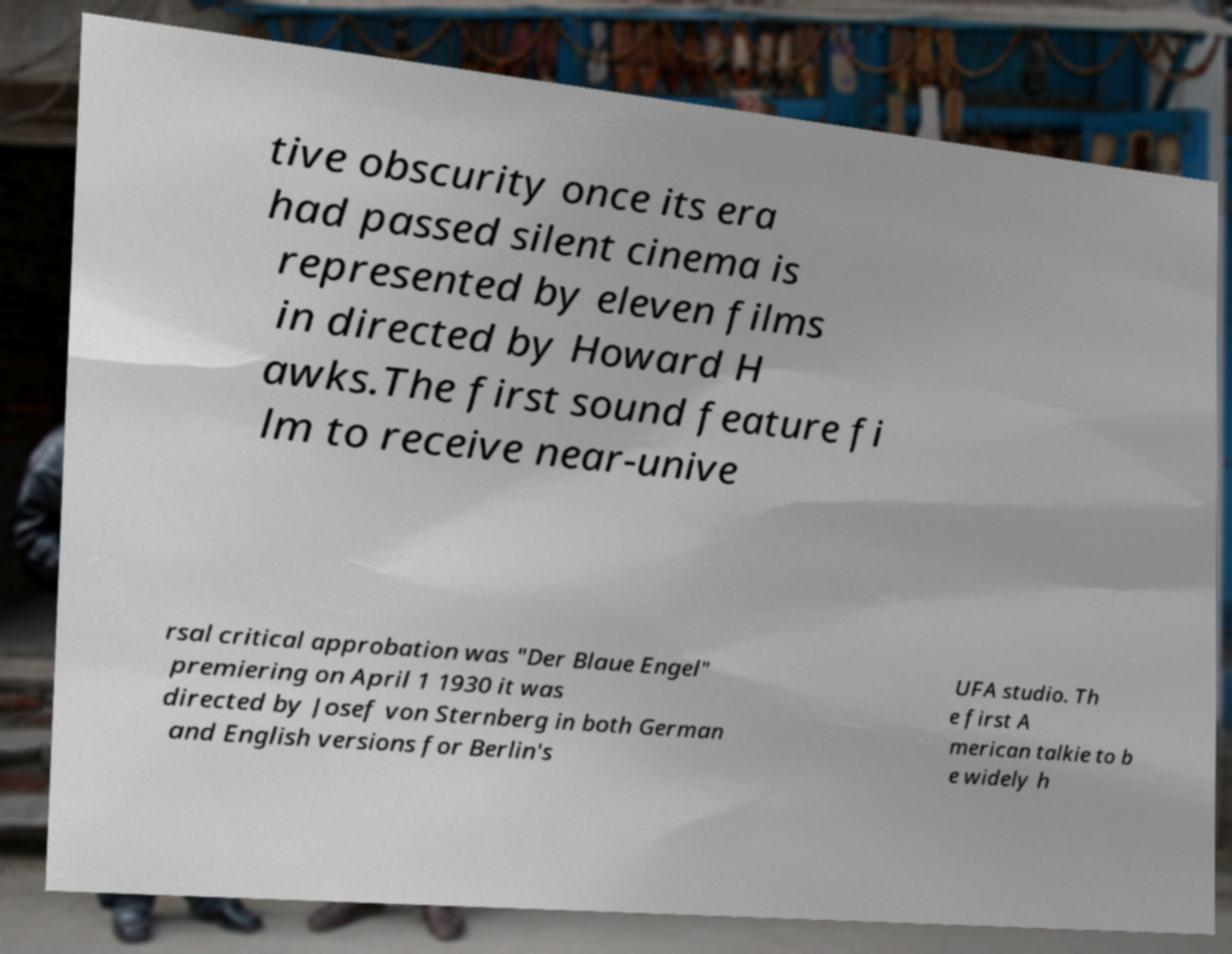Could you extract and type out the text from this image? tive obscurity once its era had passed silent cinema is represented by eleven films in directed by Howard H awks.The first sound feature fi lm to receive near-unive rsal critical approbation was "Der Blaue Engel" premiering on April 1 1930 it was directed by Josef von Sternberg in both German and English versions for Berlin's UFA studio. Th e first A merican talkie to b e widely h 